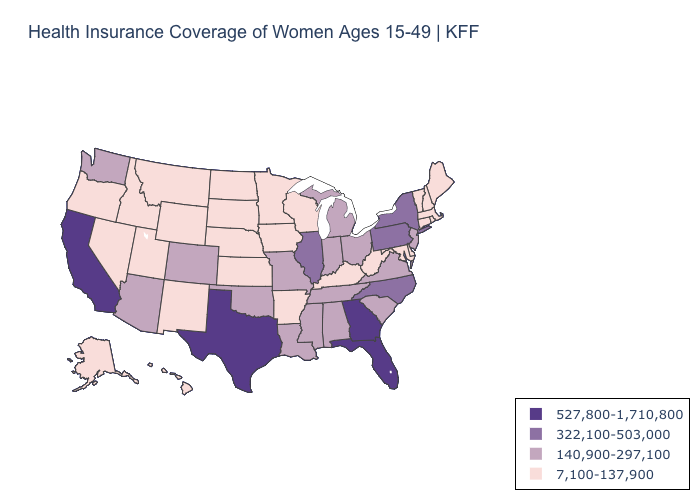Does Texas have the highest value in the USA?
Be succinct. Yes. What is the value of Virginia?
Give a very brief answer. 140,900-297,100. Does the map have missing data?
Answer briefly. No. Among the states that border Florida , does Georgia have the lowest value?
Keep it brief. No. What is the value of Ohio?
Concise answer only. 140,900-297,100. What is the lowest value in the USA?
Concise answer only. 7,100-137,900. Name the states that have a value in the range 527,800-1,710,800?
Answer briefly. California, Florida, Georgia, Texas. Name the states that have a value in the range 140,900-297,100?
Write a very short answer. Alabama, Arizona, Colorado, Indiana, Louisiana, Michigan, Mississippi, Missouri, New Jersey, Ohio, Oklahoma, South Carolina, Tennessee, Virginia, Washington. What is the highest value in states that border California?
Give a very brief answer. 140,900-297,100. What is the lowest value in the USA?
Answer briefly. 7,100-137,900. What is the lowest value in the MidWest?
Keep it brief. 7,100-137,900. Which states have the lowest value in the South?
Quick response, please. Arkansas, Delaware, Kentucky, Maryland, West Virginia. Name the states that have a value in the range 140,900-297,100?
Short answer required. Alabama, Arizona, Colorado, Indiana, Louisiana, Michigan, Mississippi, Missouri, New Jersey, Ohio, Oklahoma, South Carolina, Tennessee, Virginia, Washington. Name the states that have a value in the range 527,800-1,710,800?
Short answer required. California, Florida, Georgia, Texas. Name the states that have a value in the range 140,900-297,100?
Short answer required. Alabama, Arizona, Colorado, Indiana, Louisiana, Michigan, Mississippi, Missouri, New Jersey, Ohio, Oklahoma, South Carolina, Tennessee, Virginia, Washington. 